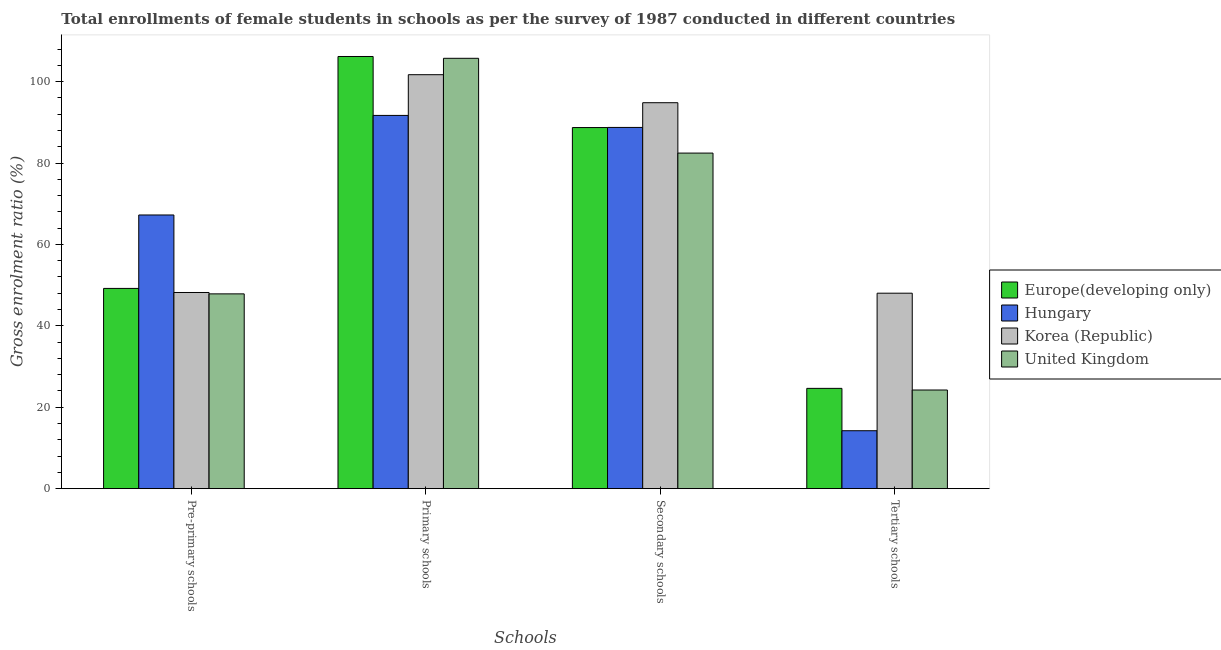How many groups of bars are there?
Your answer should be compact. 4. How many bars are there on the 4th tick from the right?
Provide a succinct answer. 4. What is the label of the 2nd group of bars from the left?
Keep it short and to the point. Primary schools. What is the gross enrolment ratio(female) in tertiary schools in Europe(developing only)?
Give a very brief answer. 24.64. Across all countries, what is the maximum gross enrolment ratio(female) in pre-primary schools?
Offer a terse response. 67.23. Across all countries, what is the minimum gross enrolment ratio(female) in primary schools?
Ensure brevity in your answer.  91.69. In which country was the gross enrolment ratio(female) in pre-primary schools maximum?
Offer a very short reply. Hungary. In which country was the gross enrolment ratio(female) in pre-primary schools minimum?
Ensure brevity in your answer.  United Kingdom. What is the total gross enrolment ratio(female) in pre-primary schools in the graph?
Provide a short and direct response. 212.48. What is the difference between the gross enrolment ratio(female) in secondary schools in United Kingdom and that in Korea (Republic)?
Give a very brief answer. -12.37. What is the difference between the gross enrolment ratio(female) in tertiary schools in Hungary and the gross enrolment ratio(female) in pre-primary schools in United Kingdom?
Provide a short and direct response. -33.62. What is the average gross enrolment ratio(female) in tertiary schools per country?
Your response must be concise. 27.78. What is the difference between the gross enrolment ratio(female) in primary schools and gross enrolment ratio(female) in tertiary schools in United Kingdom?
Your response must be concise. 81.48. In how many countries, is the gross enrolment ratio(female) in pre-primary schools greater than 52 %?
Ensure brevity in your answer.  1. What is the ratio of the gross enrolment ratio(female) in secondary schools in Hungary to that in United Kingdom?
Give a very brief answer. 1.08. Is the gross enrolment ratio(female) in secondary schools in Korea (Republic) less than that in Hungary?
Offer a terse response. No. Is the difference between the gross enrolment ratio(female) in secondary schools in Europe(developing only) and Hungary greater than the difference between the gross enrolment ratio(female) in pre-primary schools in Europe(developing only) and Hungary?
Provide a succinct answer. Yes. What is the difference between the highest and the second highest gross enrolment ratio(female) in tertiary schools?
Provide a short and direct response. 23.38. What is the difference between the highest and the lowest gross enrolment ratio(female) in secondary schools?
Ensure brevity in your answer.  12.37. Is the sum of the gross enrolment ratio(female) in primary schools in Korea (Republic) and Europe(developing only) greater than the maximum gross enrolment ratio(female) in pre-primary schools across all countries?
Provide a succinct answer. Yes. What does the 2nd bar from the left in Tertiary schools represents?
Offer a terse response. Hungary. What does the 3rd bar from the right in Primary schools represents?
Your response must be concise. Hungary. Is it the case that in every country, the sum of the gross enrolment ratio(female) in pre-primary schools and gross enrolment ratio(female) in primary schools is greater than the gross enrolment ratio(female) in secondary schools?
Your answer should be compact. Yes. Are all the bars in the graph horizontal?
Ensure brevity in your answer.  No. What is the difference between two consecutive major ticks on the Y-axis?
Offer a very short reply. 20. Does the graph contain any zero values?
Provide a succinct answer. No. Where does the legend appear in the graph?
Your answer should be compact. Center right. How many legend labels are there?
Provide a short and direct response. 4. What is the title of the graph?
Offer a terse response. Total enrollments of female students in schools as per the survey of 1987 conducted in different countries. What is the label or title of the X-axis?
Offer a very short reply. Schools. What is the label or title of the Y-axis?
Give a very brief answer. Gross enrolment ratio (%). What is the Gross enrolment ratio (%) of Europe(developing only) in Pre-primary schools?
Ensure brevity in your answer.  49.19. What is the Gross enrolment ratio (%) of Hungary in Pre-primary schools?
Provide a succinct answer. 67.23. What is the Gross enrolment ratio (%) in Korea (Republic) in Pre-primary schools?
Offer a very short reply. 48.19. What is the Gross enrolment ratio (%) of United Kingdom in Pre-primary schools?
Provide a succinct answer. 47.86. What is the Gross enrolment ratio (%) in Europe(developing only) in Primary schools?
Your response must be concise. 106.17. What is the Gross enrolment ratio (%) in Hungary in Primary schools?
Give a very brief answer. 91.69. What is the Gross enrolment ratio (%) in Korea (Republic) in Primary schools?
Provide a succinct answer. 101.69. What is the Gross enrolment ratio (%) of United Kingdom in Primary schools?
Offer a terse response. 105.72. What is the Gross enrolment ratio (%) in Europe(developing only) in Secondary schools?
Provide a short and direct response. 88.71. What is the Gross enrolment ratio (%) of Hungary in Secondary schools?
Make the answer very short. 88.74. What is the Gross enrolment ratio (%) of Korea (Republic) in Secondary schools?
Your answer should be very brief. 94.81. What is the Gross enrolment ratio (%) of United Kingdom in Secondary schools?
Offer a terse response. 82.44. What is the Gross enrolment ratio (%) of Europe(developing only) in Tertiary schools?
Your answer should be compact. 24.64. What is the Gross enrolment ratio (%) in Hungary in Tertiary schools?
Offer a very short reply. 14.23. What is the Gross enrolment ratio (%) in Korea (Republic) in Tertiary schools?
Offer a terse response. 48.02. What is the Gross enrolment ratio (%) of United Kingdom in Tertiary schools?
Make the answer very short. 24.24. Across all Schools, what is the maximum Gross enrolment ratio (%) in Europe(developing only)?
Your answer should be compact. 106.17. Across all Schools, what is the maximum Gross enrolment ratio (%) of Hungary?
Make the answer very short. 91.69. Across all Schools, what is the maximum Gross enrolment ratio (%) of Korea (Republic)?
Provide a succinct answer. 101.69. Across all Schools, what is the maximum Gross enrolment ratio (%) of United Kingdom?
Keep it short and to the point. 105.72. Across all Schools, what is the minimum Gross enrolment ratio (%) of Europe(developing only)?
Keep it short and to the point. 24.64. Across all Schools, what is the minimum Gross enrolment ratio (%) of Hungary?
Your answer should be compact. 14.23. Across all Schools, what is the minimum Gross enrolment ratio (%) of Korea (Republic)?
Offer a terse response. 48.02. Across all Schools, what is the minimum Gross enrolment ratio (%) in United Kingdom?
Make the answer very short. 24.24. What is the total Gross enrolment ratio (%) of Europe(developing only) in the graph?
Provide a short and direct response. 268.71. What is the total Gross enrolment ratio (%) in Hungary in the graph?
Keep it short and to the point. 261.9. What is the total Gross enrolment ratio (%) of Korea (Republic) in the graph?
Provide a short and direct response. 292.72. What is the total Gross enrolment ratio (%) in United Kingdom in the graph?
Your response must be concise. 260.25. What is the difference between the Gross enrolment ratio (%) of Europe(developing only) in Pre-primary schools and that in Primary schools?
Your answer should be very brief. -56.98. What is the difference between the Gross enrolment ratio (%) of Hungary in Pre-primary schools and that in Primary schools?
Your answer should be compact. -24.46. What is the difference between the Gross enrolment ratio (%) of Korea (Republic) in Pre-primary schools and that in Primary schools?
Keep it short and to the point. -53.5. What is the difference between the Gross enrolment ratio (%) of United Kingdom in Pre-primary schools and that in Primary schools?
Give a very brief answer. -57.87. What is the difference between the Gross enrolment ratio (%) in Europe(developing only) in Pre-primary schools and that in Secondary schools?
Provide a short and direct response. -39.52. What is the difference between the Gross enrolment ratio (%) of Hungary in Pre-primary schools and that in Secondary schools?
Keep it short and to the point. -21.5. What is the difference between the Gross enrolment ratio (%) in Korea (Republic) in Pre-primary schools and that in Secondary schools?
Keep it short and to the point. -46.62. What is the difference between the Gross enrolment ratio (%) in United Kingdom in Pre-primary schools and that in Secondary schools?
Your answer should be very brief. -34.58. What is the difference between the Gross enrolment ratio (%) in Europe(developing only) in Pre-primary schools and that in Tertiary schools?
Your response must be concise. 24.55. What is the difference between the Gross enrolment ratio (%) of Hungary in Pre-primary schools and that in Tertiary schools?
Your answer should be compact. 53. What is the difference between the Gross enrolment ratio (%) of Korea (Republic) in Pre-primary schools and that in Tertiary schools?
Your answer should be very brief. 0.18. What is the difference between the Gross enrolment ratio (%) of United Kingdom in Pre-primary schools and that in Tertiary schools?
Keep it short and to the point. 23.62. What is the difference between the Gross enrolment ratio (%) of Europe(developing only) in Primary schools and that in Secondary schools?
Offer a very short reply. 17.46. What is the difference between the Gross enrolment ratio (%) in Hungary in Primary schools and that in Secondary schools?
Provide a short and direct response. 2.95. What is the difference between the Gross enrolment ratio (%) of Korea (Republic) in Primary schools and that in Secondary schools?
Provide a succinct answer. 6.88. What is the difference between the Gross enrolment ratio (%) of United Kingdom in Primary schools and that in Secondary schools?
Offer a terse response. 23.28. What is the difference between the Gross enrolment ratio (%) of Europe(developing only) in Primary schools and that in Tertiary schools?
Keep it short and to the point. 81.53. What is the difference between the Gross enrolment ratio (%) of Hungary in Primary schools and that in Tertiary schools?
Provide a succinct answer. 77.46. What is the difference between the Gross enrolment ratio (%) of Korea (Republic) in Primary schools and that in Tertiary schools?
Offer a terse response. 53.67. What is the difference between the Gross enrolment ratio (%) of United Kingdom in Primary schools and that in Tertiary schools?
Your answer should be compact. 81.48. What is the difference between the Gross enrolment ratio (%) in Europe(developing only) in Secondary schools and that in Tertiary schools?
Keep it short and to the point. 64.07. What is the difference between the Gross enrolment ratio (%) in Hungary in Secondary schools and that in Tertiary schools?
Give a very brief answer. 74.51. What is the difference between the Gross enrolment ratio (%) in Korea (Republic) in Secondary schools and that in Tertiary schools?
Your answer should be compact. 46.79. What is the difference between the Gross enrolment ratio (%) in United Kingdom in Secondary schools and that in Tertiary schools?
Your answer should be very brief. 58.2. What is the difference between the Gross enrolment ratio (%) in Europe(developing only) in Pre-primary schools and the Gross enrolment ratio (%) in Hungary in Primary schools?
Give a very brief answer. -42.5. What is the difference between the Gross enrolment ratio (%) of Europe(developing only) in Pre-primary schools and the Gross enrolment ratio (%) of Korea (Republic) in Primary schools?
Your response must be concise. -52.5. What is the difference between the Gross enrolment ratio (%) in Europe(developing only) in Pre-primary schools and the Gross enrolment ratio (%) in United Kingdom in Primary schools?
Your response must be concise. -56.53. What is the difference between the Gross enrolment ratio (%) in Hungary in Pre-primary schools and the Gross enrolment ratio (%) in Korea (Republic) in Primary schools?
Keep it short and to the point. -34.46. What is the difference between the Gross enrolment ratio (%) of Hungary in Pre-primary schools and the Gross enrolment ratio (%) of United Kingdom in Primary schools?
Make the answer very short. -38.49. What is the difference between the Gross enrolment ratio (%) in Korea (Republic) in Pre-primary schools and the Gross enrolment ratio (%) in United Kingdom in Primary schools?
Offer a terse response. -57.53. What is the difference between the Gross enrolment ratio (%) of Europe(developing only) in Pre-primary schools and the Gross enrolment ratio (%) of Hungary in Secondary schools?
Your response must be concise. -39.55. What is the difference between the Gross enrolment ratio (%) of Europe(developing only) in Pre-primary schools and the Gross enrolment ratio (%) of Korea (Republic) in Secondary schools?
Keep it short and to the point. -45.62. What is the difference between the Gross enrolment ratio (%) in Europe(developing only) in Pre-primary schools and the Gross enrolment ratio (%) in United Kingdom in Secondary schools?
Keep it short and to the point. -33.24. What is the difference between the Gross enrolment ratio (%) in Hungary in Pre-primary schools and the Gross enrolment ratio (%) in Korea (Republic) in Secondary schools?
Keep it short and to the point. -27.58. What is the difference between the Gross enrolment ratio (%) of Hungary in Pre-primary schools and the Gross enrolment ratio (%) of United Kingdom in Secondary schools?
Your answer should be very brief. -15.2. What is the difference between the Gross enrolment ratio (%) of Korea (Republic) in Pre-primary schools and the Gross enrolment ratio (%) of United Kingdom in Secondary schools?
Your response must be concise. -34.24. What is the difference between the Gross enrolment ratio (%) of Europe(developing only) in Pre-primary schools and the Gross enrolment ratio (%) of Hungary in Tertiary schools?
Give a very brief answer. 34.96. What is the difference between the Gross enrolment ratio (%) in Europe(developing only) in Pre-primary schools and the Gross enrolment ratio (%) in Korea (Republic) in Tertiary schools?
Make the answer very short. 1.17. What is the difference between the Gross enrolment ratio (%) of Europe(developing only) in Pre-primary schools and the Gross enrolment ratio (%) of United Kingdom in Tertiary schools?
Your answer should be very brief. 24.95. What is the difference between the Gross enrolment ratio (%) of Hungary in Pre-primary schools and the Gross enrolment ratio (%) of Korea (Republic) in Tertiary schools?
Give a very brief answer. 19.22. What is the difference between the Gross enrolment ratio (%) in Hungary in Pre-primary schools and the Gross enrolment ratio (%) in United Kingdom in Tertiary schools?
Keep it short and to the point. 43. What is the difference between the Gross enrolment ratio (%) in Korea (Republic) in Pre-primary schools and the Gross enrolment ratio (%) in United Kingdom in Tertiary schools?
Your answer should be very brief. 23.96. What is the difference between the Gross enrolment ratio (%) of Europe(developing only) in Primary schools and the Gross enrolment ratio (%) of Hungary in Secondary schools?
Offer a very short reply. 17.43. What is the difference between the Gross enrolment ratio (%) in Europe(developing only) in Primary schools and the Gross enrolment ratio (%) in Korea (Republic) in Secondary schools?
Your answer should be compact. 11.36. What is the difference between the Gross enrolment ratio (%) of Europe(developing only) in Primary schools and the Gross enrolment ratio (%) of United Kingdom in Secondary schools?
Provide a short and direct response. 23.73. What is the difference between the Gross enrolment ratio (%) in Hungary in Primary schools and the Gross enrolment ratio (%) in Korea (Republic) in Secondary schools?
Give a very brief answer. -3.12. What is the difference between the Gross enrolment ratio (%) in Hungary in Primary schools and the Gross enrolment ratio (%) in United Kingdom in Secondary schools?
Ensure brevity in your answer.  9.25. What is the difference between the Gross enrolment ratio (%) of Korea (Republic) in Primary schools and the Gross enrolment ratio (%) of United Kingdom in Secondary schools?
Your answer should be compact. 19.26. What is the difference between the Gross enrolment ratio (%) in Europe(developing only) in Primary schools and the Gross enrolment ratio (%) in Hungary in Tertiary schools?
Provide a short and direct response. 91.93. What is the difference between the Gross enrolment ratio (%) in Europe(developing only) in Primary schools and the Gross enrolment ratio (%) in Korea (Republic) in Tertiary schools?
Your response must be concise. 58.15. What is the difference between the Gross enrolment ratio (%) in Europe(developing only) in Primary schools and the Gross enrolment ratio (%) in United Kingdom in Tertiary schools?
Offer a terse response. 81.93. What is the difference between the Gross enrolment ratio (%) in Hungary in Primary schools and the Gross enrolment ratio (%) in Korea (Republic) in Tertiary schools?
Your answer should be compact. 43.67. What is the difference between the Gross enrolment ratio (%) of Hungary in Primary schools and the Gross enrolment ratio (%) of United Kingdom in Tertiary schools?
Your answer should be compact. 67.45. What is the difference between the Gross enrolment ratio (%) in Korea (Republic) in Primary schools and the Gross enrolment ratio (%) in United Kingdom in Tertiary schools?
Provide a succinct answer. 77.45. What is the difference between the Gross enrolment ratio (%) of Europe(developing only) in Secondary schools and the Gross enrolment ratio (%) of Hungary in Tertiary schools?
Ensure brevity in your answer.  74.47. What is the difference between the Gross enrolment ratio (%) of Europe(developing only) in Secondary schools and the Gross enrolment ratio (%) of Korea (Republic) in Tertiary schools?
Offer a very short reply. 40.69. What is the difference between the Gross enrolment ratio (%) in Europe(developing only) in Secondary schools and the Gross enrolment ratio (%) in United Kingdom in Tertiary schools?
Ensure brevity in your answer.  64.47. What is the difference between the Gross enrolment ratio (%) in Hungary in Secondary schools and the Gross enrolment ratio (%) in Korea (Republic) in Tertiary schools?
Your response must be concise. 40.72. What is the difference between the Gross enrolment ratio (%) of Hungary in Secondary schools and the Gross enrolment ratio (%) of United Kingdom in Tertiary schools?
Provide a succinct answer. 64.5. What is the difference between the Gross enrolment ratio (%) in Korea (Republic) in Secondary schools and the Gross enrolment ratio (%) in United Kingdom in Tertiary schools?
Ensure brevity in your answer.  70.57. What is the average Gross enrolment ratio (%) of Europe(developing only) per Schools?
Your answer should be compact. 67.18. What is the average Gross enrolment ratio (%) of Hungary per Schools?
Give a very brief answer. 65.48. What is the average Gross enrolment ratio (%) in Korea (Republic) per Schools?
Offer a terse response. 73.18. What is the average Gross enrolment ratio (%) in United Kingdom per Schools?
Make the answer very short. 65.06. What is the difference between the Gross enrolment ratio (%) of Europe(developing only) and Gross enrolment ratio (%) of Hungary in Pre-primary schools?
Your response must be concise. -18.04. What is the difference between the Gross enrolment ratio (%) in Europe(developing only) and Gross enrolment ratio (%) in United Kingdom in Pre-primary schools?
Offer a very short reply. 1.34. What is the difference between the Gross enrolment ratio (%) in Hungary and Gross enrolment ratio (%) in Korea (Republic) in Pre-primary schools?
Offer a terse response. 19.04. What is the difference between the Gross enrolment ratio (%) in Hungary and Gross enrolment ratio (%) in United Kingdom in Pre-primary schools?
Offer a very short reply. 19.38. What is the difference between the Gross enrolment ratio (%) in Korea (Republic) and Gross enrolment ratio (%) in United Kingdom in Pre-primary schools?
Ensure brevity in your answer.  0.34. What is the difference between the Gross enrolment ratio (%) of Europe(developing only) and Gross enrolment ratio (%) of Hungary in Primary schools?
Offer a very short reply. 14.48. What is the difference between the Gross enrolment ratio (%) of Europe(developing only) and Gross enrolment ratio (%) of Korea (Republic) in Primary schools?
Make the answer very short. 4.47. What is the difference between the Gross enrolment ratio (%) of Europe(developing only) and Gross enrolment ratio (%) of United Kingdom in Primary schools?
Your response must be concise. 0.45. What is the difference between the Gross enrolment ratio (%) in Hungary and Gross enrolment ratio (%) in Korea (Republic) in Primary schools?
Make the answer very short. -10. What is the difference between the Gross enrolment ratio (%) of Hungary and Gross enrolment ratio (%) of United Kingdom in Primary schools?
Provide a short and direct response. -14.03. What is the difference between the Gross enrolment ratio (%) of Korea (Republic) and Gross enrolment ratio (%) of United Kingdom in Primary schools?
Keep it short and to the point. -4.03. What is the difference between the Gross enrolment ratio (%) in Europe(developing only) and Gross enrolment ratio (%) in Hungary in Secondary schools?
Offer a very short reply. -0.03. What is the difference between the Gross enrolment ratio (%) of Europe(developing only) and Gross enrolment ratio (%) of Korea (Republic) in Secondary schools?
Keep it short and to the point. -6.1. What is the difference between the Gross enrolment ratio (%) of Europe(developing only) and Gross enrolment ratio (%) of United Kingdom in Secondary schools?
Your answer should be very brief. 6.27. What is the difference between the Gross enrolment ratio (%) of Hungary and Gross enrolment ratio (%) of Korea (Republic) in Secondary schools?
Your answer should be very brief. -6.07. What is the difference between the Gross enrolment ratio (%) of Hungary and Gross enrolment ratio (%) of United Kingdom in Secondary schools?
Ensure brevity in your answer.  6.3. What is the difference between the Gross enrolment ratio (%) of Korea (Republic) and Gross enrolment ratio (%) of United Kingdom in Secondary schools?
Ensure brevity in your answer.  12.37. What is the difference between the Gross enrolment ratio (%) in Europe(developing only) and Gross enrolment ratio (%) in Hungary in Tertiary schools?
Your answer should be compact. 10.41. What is the difference between the Gross enrolment ratio (%) of Europe(developing only) and Gross enrolment ratio (%) of Korea (Republic) in Tertiary schools?
Ensure brevity in your answer.  -23.38. What is the difference between the Gross enrolment ratio (%) in Europe(developing only) and Gross enrolment ratio (%) in United Kingdom in Tertiary schools?
Provide a short and direct response. 0.4. What is the difference between the Gross enrolment ratio (%) in Hungary and Gross enrolment ratio (%) in Korea (Republic) in Tertiary schools?
Your answer should be compact. -33.78. What is the difference between the Gross enrolment ratio (%) of Hungary and Gross enrolment ratio (%) of United Kingdom in Tertiary schools?
Your answer should be compact. -10. What is the difference between the Gross enrolment ratio (%) in Korea (Republic) and Gross enrolment ratio (%) in United Kingdom in Tertiary schools?
Make the answer very short. 23.78. What is the ratio of the Gross enrolment ratio (%) in Europe(developing only) in Pre-primary schools to that in Primary schools?
Your answer should be very brief. 0.46. What is the ratio of the Gross enrolment ratio (%) in Hungary in Pre-primary schools to that in Primary schools?
Give a very brief answer. 0.73. What is the ratio of the Gross enrolment ratio (%) in Korea (Republic) in Pre-primary schools to that in Primary schools?
Provide a short and direct response. 0.47. What is the ratio of the Gross enrolment ratio (%) in United Kingdom in Pre-primary schools to that in Primary schools?
Your answer should be very brief. 0.45. What is the ratio of the Gross enrolment ratio (%) in Europe(developing only) in Pre-primary schools to that in Secondary schools?
Make the answer very short. 0.55. What is the ratio of the Gross enrolment ratio (%) in Hungary in Pre-primary schools to that in Secondary schools?
Offer a very short reply. 0.76. What is the ratio of the Gross enrolment ratio (%) of Korea (Republic) in Pre-primary schools to that in Secondary schools?
Offer a terse response. 0.51. What is the ratio of the Gross enrolment ratio (%) of United Kingdom in Pre-primary schools to that in Secondary schools?
Give a very brief answer. 0.58. What is the ratio of the Gross enrolment ratio (%) of Europe(developing only) in Pre-primary schools to that in Tertiary schools?
Your answer should be compact. 2. What is the ratio of the Gross enrolment ratio (%) in Hungary in Pre-primary schools to that in Tertiary schools?
Your answer should be very brief. 4.72. What is the ratio of the Gross enrolment ratio (%) in United Kingdom in Pre-primary schools to that in Tertiary schools?
Your answer should be very brief. 1.97. What is the ratio of the Gross enrolment ratio (%) in Europe(developing only) in Primary schools to that in Secondary schools?
Your answer should be compact. 1.2. What is the ratio of the Gross enrolment ratio (%) of Hungary in Primary schools to that in Secondary schools?
Make the answer very short. 1.03. What is the ratio of the Gross enrolment ratio (%) of Korea (Republic) in Primary schools to that in Secondary schools?
Provide a succinct answer. 1.07. What is the ratio of the Gross enrolment ratio (%) of United Kingdom in Primary schools to that in Secondary schools?
Provide a short and direct response. 1.28. What is the ratio of the Gross enrolment ratio (%) in Europe(developing only) in Primary schools to that in Tertiary schools?
Keep it short and to the point. 4.31. What is the ratio of the Gross enrolment ratio (%) of Hungary in Primary schools to that in Tertiary schools?
Give a very brief answer. 6.44. What is the ratio of the Gross enrolment ratio (%) in Korea (Republic) in Primary schools to that in Tertiary schools?
Offer a very short reply. 2.12. What is the ratio of the Gross enrolment ratio (%) in United Kingdom in Primary schools to that in Tertiary schools?
Your response must be concise. 4.36. What is the ratio of the Gross enrolment ratio (%) in Europe(developing only) in Secondary schools to that in Tertiary schools?
Your answer should be compact. 3.6. What is the ratio of the Gross enrolment ratio (%) in Hungary in Secondary schools to that in Tertiary schools?
Provide a short and direct response. 6.23. What is the ratio of the Gross enrolment ratio (%) in Korea (Republic) in Secondary schools to that in Tertiary schools?
Ensure brevity in your answer.  1.97. What is the ratio of the Gross enrolment ratio (%) in United Kingdom in Secondary schools to that in Tertiary schools?
Keep it short and to the point. 3.4. What is the difference between the highest and the second highest Gross enrolment ratio (%) in Europe(developing only)?
Offer a terse response. 17.46. What is the difference between the highest and the second highest Gross enrolment ratio (%) of Hungary?
Your response must be concise. 2.95. What is the difference between the highest and the second highest Gross enrolment ratio (%) in Korea (Republic)?
Provide a short and direct response. 6.88. What is the difference between the highest and the second highest Gross enrolment ratio (%) of United Kingdom?
Make the answer very short. 23.28. What is the difference between the highest and the lowest Gross enrolment ratio (%) of Europe(developing only)?
Your answer should be compact. 81.53. What is the difference between the highest and the lowest Gross enrolment ratio (%) of Hungary?
Offer a very short reply. 77.46. What is the difference between the highest and the lowest Gross enrolment ratio (%) in Korea (Republic)?
Your answer should be very brief. 53.67. What is the difference between the highest and the lowest Gross enrolment ratio (%) in United Kingdom?
Your answer should be very brief. 81.48. 